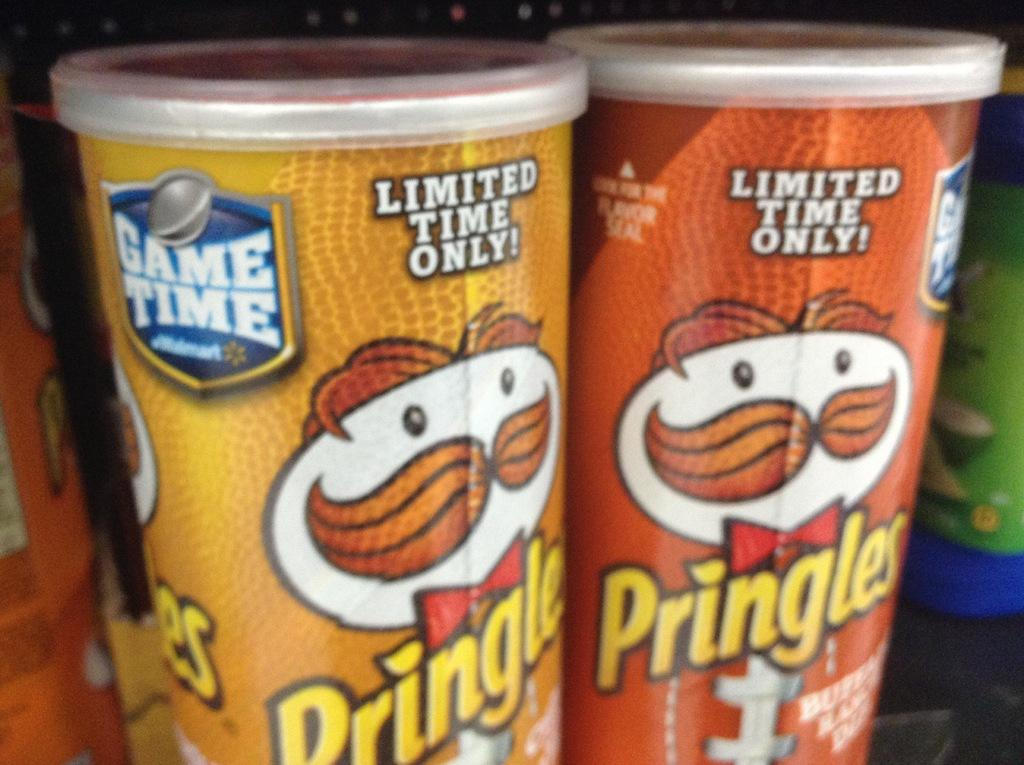<image>
Provide a brief description of the given image. Two cans of Pringles have a guy with a mustache and a bow tie. 